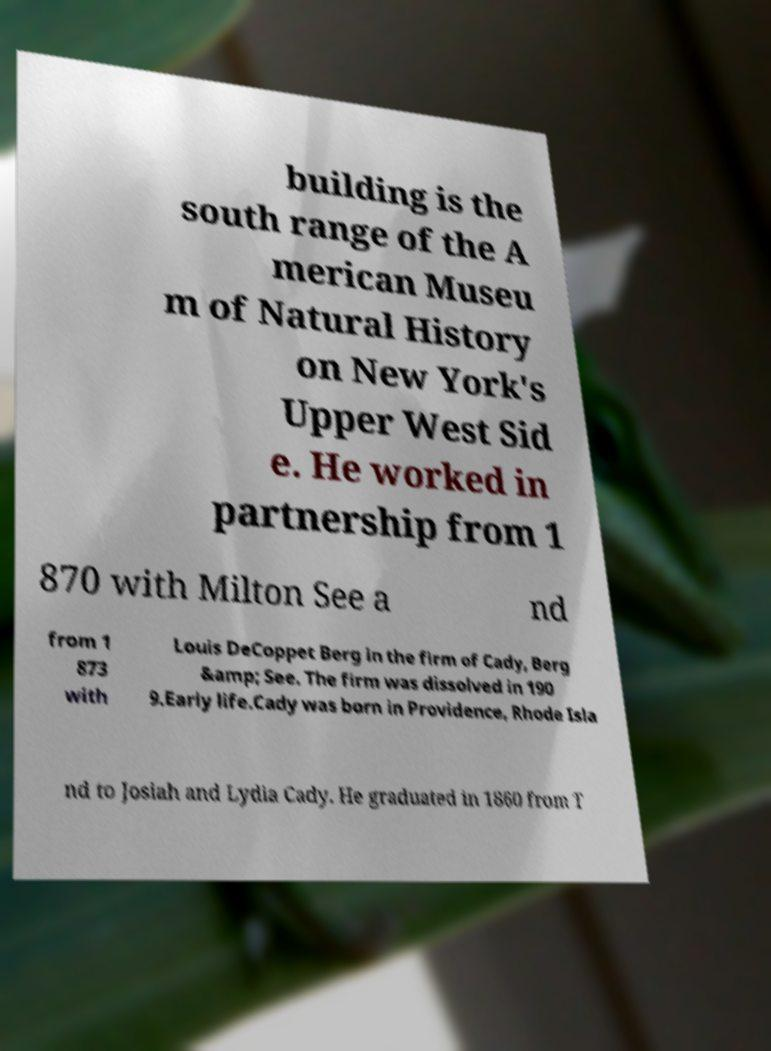For documentation purposes, I need the text within this image transcribed. Could you provide that? building is the south range of the A merican Museu m of Natural History on New York's Upper West Sid e. He worked in partnership from 1 870 with Milton See a nd from 1 873 with Louis DeCoppet Berg in the firm of Cady, Berg &amp; See. The firm was dissolved in 190 9.Early life.Cady was born in Providence, Rhode Isla nd to Josiah and Lydia Cady. He graduated in 1860 from T 